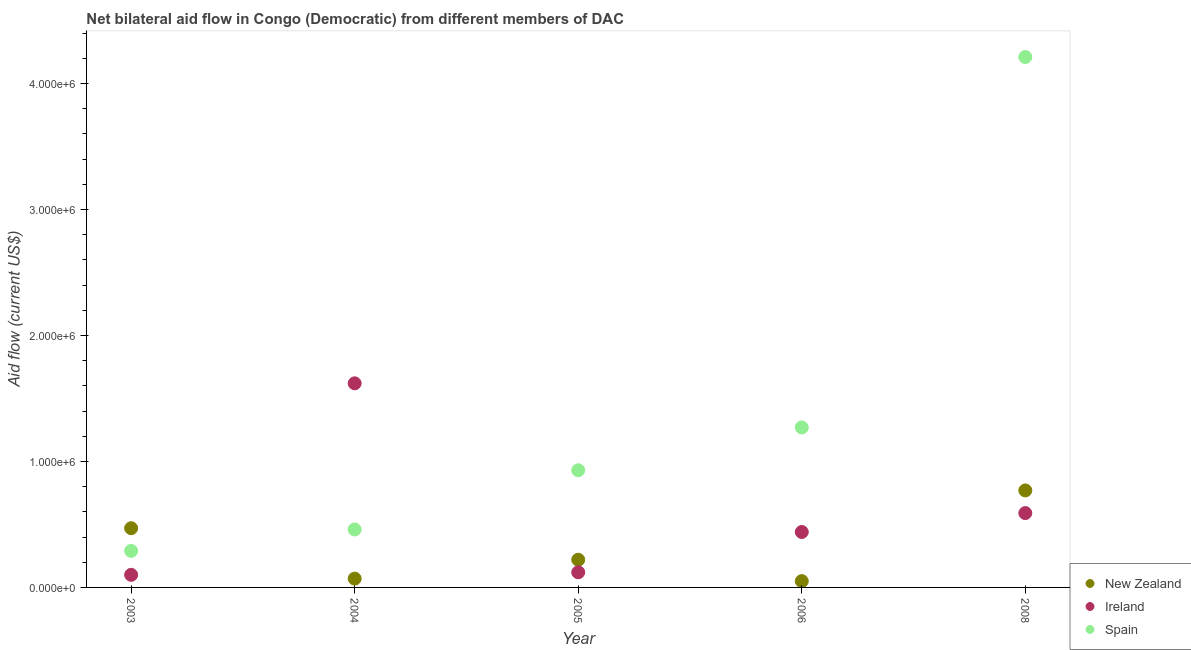How many different coloured dotlines are there?
Ensure brevity in your answer.  3. What is the amount of aid provided by spain in 2006?
Provide a succinct answer. 1.27e+06. Across all years, what is the maximum amount of aid provided by new zealand?
Your response must be concise. 7.70e+05. Across all years, what is the minimum amount of aid provided by new zealand?
Provide a succinct answer. 5.00e+04. What is the total amount of aid provided by spain in the graph?
Offer a very short reply. 7.16e+06. What is the difference between the amount of aid provided by ireland in 2003 and that in 2004?
Provide a short and direct response. -1.52e+06. What is the difference between the amount of aid provided by new zealand in 2003 and the amount of aid provided by ireland in 2006?
Offer a very short reply. 3.00e+04. What is the average amount of aid provided by new zealand per year?
Your response must be concise. 3.16e+05. In the year 2008, what is the difference between the amount of aid provided by spain and amount of aid provided by new zealand?
Provide a succinct answer. 3.44e+06. In how many years, is the amount of aid provided by new zealand greater than 2800000 US$?
Give a very brief answer. 0. What is the ratio of the amount of aid provided by ireland in 2005 to that in 2008?
Offer a terse response. 0.2. What is the difference between the highest and the second highest amount of aid provided by ireland?
Provide a succinct answer. 1.03e+06. What is the difference between the highest and the lowest amount of aid provided by ireland?
Your answer should be very brief. 1.52e+06. Is the sum of the amount of aid provided by ireland in 2006 and 2008 greater than the maximum amount of aid provided by spain across all years?
Keep it short and to the point. No. Does the amount of aid provided by ireland monotonically increase over the years?
Keep it short and to the point. No. Is the amount of aid provided by ireland strictly greater than the amount of aid provided by spain over the years?
Your response must be concise. No. How many years are there in the graph?
Provide a short and direct response. 5. Are the values on the major ticks of Y-axis written in scientific E-notation?
Provide a succinct answer. Yes. How many legend labels are there?
Offer a very short reply. 3. What is the title of the graph?
Provide a short and direct response. Net bilateral aid flow in Congo (Democratic) from different members of DAC. Does "Czech Republic" appear as one of the legend labels in the graph?
Your response must be concise. No. What is the label or title of the X-axis?
Keep it short and to the point. Year. What is the Aid flow (current US$) in Spain in 2003?
Keep it short and to the point. 2.90e+05. What is the Aid flow (current US$) of Ireland in 2004?
Provide a short and direct response. 1.62e+06. What is the Aid flow (current US$) of Spain in 2004?
Ensure brevity in your answer.  4.60e+05. What is the Aid flow (current US$) of New Zealand in 2005?
Offer a very short reply. 2.20e+05. What is the Aid flow (current US$) of Spain in 2005?
Keep it short and to the point. 9.30e+05. What is the Aid flow (current US$) of New Zealand in 2006?
Your response must be concise. 5.00e+04. What is the Aid flow (current US$) in Spain in 2006?
Provide a short and direct response. 1.27e+06. What is the Aid flow (current US$) of New Zealand in 2008?
Offer a very short reply. 7.70e+05. What is the Aid flow (current US$) of Ireland in 2008?
Your response must be concise. 5.90e+05. What is the Aid flow (current US$) in Spain in 2008?
Keep it short and to the point. 4.21e+06. Across all years, what is the maximum Aid flow (current US$) in New Zealand?
Your response must be concise. 7.70e+05. Across all years, what is the maximum Aid flow (current US$) in Ireland?
Keep it short and to the point. 1.62e+06. Across all years, what is the maximum Aid flow (current US$) of Spain?
Provide a succinct answer. 4.21e+06. Across all years, what is the minimum Aid flow (current US$) of New Zealand?
Keep it short and to the point. 5.00e+04. Across all years, what is the minimum Aid flow (current US$) of Ireland?
Make the answer very short. 1.00e+05. What is the total Aid flow (current US$) in New Zealand in the graph?
Ensure brevity in your answer.  1.58e+06. What is the total Aid flow (current US$) of Ireland in the graph?
Keep it short and to the point. 2.87e+06. What is the total Aid flow (current US$) in Spain in the graph?
Offer a terse response. 7.16e+06. What is the difference between the Aid flow (current US$) of New Zealand in 2003 and that in 2004?
Offer a very short reply. 4.00e+05. What is the difference between the Aid flow (current US$) of Ireland in 2003 and that in 2004?
Keep it short and to the point. -1.52e+06. What is the difference between the Aid flow (current US$) in Spain in 2003 and that in 2004?
Offer a terse response. -1.70e+05. What is the difference between the Aid flow (current US$) in New Zealand in 2003 and that in 2005?
Ensure brevity in your answer.  2.50e+05. What is the difference between the Aid flow (current US$) in Ireland in 2003 and that in 2005?
Ensure brevity in your answer.  -2.00e+04. What is the difference between the Aid flow (current US$) in Spain in 2003 and that in 2005?
Your answer should be very brief. -6.40e+05. What is the difference between the Aid flow (current US$) in Spain in 2003 and that in 2006?
Ensure brevity in your answer.  -9.80e+05. What is the difference between the Aid flow (current US$) in New Zealand in 2003 and that in 2008?
Your response must be concise. -3.00e+05. What is the difference between the Aid flow (current US$) in Ireland in 2003 and that in 2008?
Your answer should be very brief. -4.90e+05. What is the difference between the Aid flow (current US$) of Spain in 2003 and that in 2008?
Ensure brevity in your answer.  -3.92e+06. What is the difference between the Aid flow (current US$) of Ireland in 2004 and that in 2005?
Your answer should be very brief. 1.50e+06. What is the difference between the Aid flow (current US$) of Spain in 2004 and that in 2005?
Make the answer very short. -4.70e+05. What is the difference between the Aid flow (current US$) of Ireland in 2004 and that in 2006?
Your response must be concise. 1.18e+06. What is the difference between the Aid flow (current US$) in Spain in 2004 and that in 2006?
Your answer should be very brief. -8.10e+05. What is the difference between the Aid flow (current US$) in New Zealand in 2004 and that in 2008?
Provide a short and direct response. -7.00e+05. What is the difference between the Aid flow (current US$) of Ireland in 2004 and that in 2008?
Provide a succinct answer. 1.03e+06. What is the difference between the Aid flow (current US$) of Spain in 2004 and that in 2008?
Provide a short and direct response. -3.75e+06. What is the difference between the Aid flow (current US$) of New Zealand in 2005 and that in 2006?
Keep it short and to the point. 1.70e+05. What is the difference between the Aid flow (current US$) of Ireland in 2005 and that in 2006?
Give a very brief answer. -3.20e+05. What is the difference between the Aid flow (current US$) of New Zealand in 2005 and that in 2008?
Ensure brevity in your answer.  -5.50e+05. What is the difference between the Aid flow (current US$) of Ireland in 2005 and that in 2008?
Offer a terse response. -4.70e+05. What is the difference between the Aid flow (current US$) in Spain in 2005 and that in 2008?
Your response must be concise. -3.28e+06. What is the difference between the Aid flow (current US$) of New Zealand in 2006 and that in 2008?
Give a very brief answer. -7.20e+05. What is the difference between the Aid flow (current US$) in Ireland in 2006 and that in 2008?
Ensure brevity in your answer.  -1.50e+05. What is the difference between the Aid flow (current US$) in Spain in 2006 and that in 2008?
Your answer should be compact. -2.94e+06. What is the difference between the Aid flow (current US$) in New Zealand in 2003 and the Aid flow (current US$) in Ireland in 2004?
Keep it short and to the point. -1.15e+06. What is the difference between the Aid flow (current US$) of New Zealand in 2003 and the Aid flow (current US$) of Spain in 2004?
Offer a terse response. 10000. What is the difference between the Aid flow (current US$) of Ireland in 2003 and the Aid flow (current US$) of Spain in 2004?
Keep it short and to the point. -3.60e+05. What is the difference between the Aid flow (current US$) in New Zealand in 2003 and the Aid flow (current US$) in Spain in 2005?
Your response must be concise. -4.60e+05. What is the difference between the Aid flow (current US$) in Ireland in 2003 and the Aid flow (current US$) in Spain in 2005?
Make the answer very short. -8.30e+05. What is the difference between the Aid flow (current US$) of New Zealand in 2003 and the Aid flow (current US$) of Spain in 2006?
Offer a terse response. -8.00e+05. What is the difference between the Aid flow (current US$) of Ireland in 2003 and the Aid flow (current US$) of Spain in 2006?
Make the answer very short. -1.17e+06. What is the difference between the Aid flow (current US$) in New Zealand in 2003 and the Aid flow (current US$) in Spain in 2008?
Give a very brief answer. -3.74e+06. What is the difference between the Aid flow (current US$) of Ireland in 2003 and the Aid flow (current US$) of Spain in 2008?
Give a very brief answer. -4.11e+06. What is the difference between the Aid flow (current US$) of New Zealand in 2004 and the Aid flow (current US$) of Ireland in 2005?
Your answer should be very brief. -5.00e+04. What is the difference between the Aid flow (current US$) in New Zealand in 2004 and the Aid flow (current US$) in Spain in 2005?
Your answer should be compact. -8.60e+05. What is the difference between the Aid flow (current US$) of Ireland in 2004 and the Aid flow (current US$) of Spain in 2005?
Give a very brief answer. 6.90e+05. What is the difference between the Aid flow (current US$) of New Zealand in 2004 and the Aid flow (current US$) of Ireland in 2006?
Your answer should be very brief. -3.70e+05. What is the difference between the Aid flow (current US$) of New Zealand in 2004 and the Aid flow (current US$) of Spain in 2006?
Your response must be concise. -1.20e+06. What is the difference between the Aid flow (current US$) of Ireland in 2004 and the Aid flow (current US$) of Spain in 2006?
Give a very brief answer. 3.50e+05. What is the difference between the Aid flow (current US$) in New Zealand in 2004 and the Aid flow (current US$) in Ireland in 2008?
Provide a short and direct response. -5.20e+05. What is the difference between the Aid flow (current US$) in New Zealand in 2004 and the Aid flow (current US$) in Spain in 2008?
Offer a very short reply. -4.14e+06. What is the difference between the Aid flow (current US$) in Ireland in 2004 and the Aid flow (current US$) in Spain in 2008?
Give a very brief answer. -2.59e+06. What is the difference between the Aid flow (current US$) of New Zealand in 2005 and the Aid flow (current US$) of Ireland in 2006?
Your response must be concise. -2.20e+05. What is the difference between the Aid flow (current US$) in New Zealand in 2005 and the Aid flow (current US$) in Spain in 2006?
Offer a terse response. -1.05e+06. What is the difference between the Aid flow (current US$) in Ireland in 2005 and the Aid flow (current US$) in Spain in 2006?
Provide a short and direct response. -1.15e+06. What is the difference between the Aid flow (current US$) in New Zealand in 2005 and the Aid flow (current US$) in Ireland in 2008?
Make the answer very short. -3.70e+05. What is the difference between the Aid flow (current US$) of New Zealand in 2005 and the Aid flow (current US$) of Spain in 2008?
Offer a very short reply. -3.99e+06. What is the difference between the Aid flow (current US$) of Ireland in 2005 and the Aid flow (current US$) of Spain in 2008?
Make the answer very short. -4.09e+06. What is the difference between the Aid flow (current US$) in New Zealand in 2006 and the Aid flow (current US$) in Ireland in 2008?
Keep it short and to the point. -5.40e+05. What is the difference between the Aid flow (current US$) in New Zealand in 2006 and the Aid flow (current US$) in Spain in 2008?
Offer a terse response. -4.16e+06. What is the difference between the Aid flow (current US$) in Ireland in 2006 and the Aid flow (current US$) in Spain in 2008?
Your answer should be very brief. -3.77e+06. What is the average Aid flow (current US$) in New Zealand per year?
Give a very brief answer. 3.16e+05. What is the average Aid flow (current US$) in Ireland per year?
Keep it short and to the point. 5.74e+05. What is the average Aid flow (current US$) of Spain per year?
Give a very brief answer. 1.43e+06. In the year 2003, what is the difference between the Aid flow (current US$) of New Zealand and Aid flow (current US$) of Ireland?
Provide a succinct answer. 3.70e+05. In the year 2004, what is the difference between the Aid flow (current US$) in New Zealand and Aid flow (current US$) in Ireland?
Provide a short and direct response. -1.55e+06. In the year 2004, what is the difference between the Aid flow (current US$) in New Zealand and Aid flow (current US$) in Spain?
Provide a succinct answer. -3.90e+05. In the year 2004, what is the difference between the Aid flow (current US$) in Ireland and Aid flow (current US$) in Spain?
Your response must be concise. 1.16e+06. In the year 2005, what is the difference between the Aid flow (current US$) in New Zealand and Aid flow (current US$) in Spain?
Provide a succinct answer. -7.10e+05. In the year 2005, what is the difference between the Aid flow (current US$) of Ireland and Aid flow (current US$) of Spain?
Keep it short and to the point. -8.10e+05. In the year 2006, what is the difference between the Aid flow (current US$) of New Zealand and Aid flow (current US$) of Ireland?
Your answer should be compact. -3.90e+05. In the year 2006, what is the difference between the Aid flow (current US$) of New Zealand and Aid flow (current US$) of Spain?
Provide a succinct answer. -1.22e+06. In the year 2006, what is the difference between the Aid flow (current US$) in Ireland and Aid flow (current US$) in Spain?
Keep it short and to the point. -8.30e+05. In the year 2008, what is the difference between the Aid flow (current US$) in New Zealand and Aid flow (current US$) in Ireland?
Make the answer very short. 1.80e+05. In the year 2008, what is the difference between the Aid flow (current US$) of New Zealand and Aid flow (current US$) of Spain?
Make the answer very short. -3.44e+06. In the year 2008, what is the difference between the Aid flow (current US$) in Ireland and Aid flow (current US$) in Spain?
Offer a very short reply. -3.62e+06. What is the ratio of the Aid flow (current US$) of New Zealand in 2003 to that in 2004?
Make the answer very short. 6.71. What is the ratio of the Aid flow (current US$) in Ireland in 2003 to that in 2004?
Offer a terse response. 0.06. What is the ratio of the Aid flow (current US$) in Spain in 2003 to that in 2004?
Make the answer very short. 0.63. What is the ratio of the Aid flow (current US$) in New Zealand in 2003 to that in 2005?
Provide a short and direct response. 2.14. What is the ratio of the Aid flow (current US$) in Spain in 2003 to that in 2005?
Offer a terse response. 0.31. What is the ratio of the Aid flow (current US$) in Ireland in 2003 to that in 2006?
Your response must be concise. 0.23. What is the ratio of the Aid flow (current US$) in Spain in 2003 to that in 2006?
Ensure brevity in your answer.  0.23. What is the ratio of the Aid flow (current US$) of New Zealand in 2003 to that in 2008?
Give a very brief answer. 0.61. What is the ratio of the Aid flow (current US$) of Ireland in 2003 to that in 2008?
Offer a terse response. 0.17. What is the ratio of the Aid flow (current US$) in Spain in 2003 to that in 2008?
Your answer should be very brief. 0.07. What is the ratio of the Aid flow (current US$) in New Zealand in 2004 to that in 2005?
Offer a terse response. 0.32. What is the ratio of the Aid flow (current US$) of Spain in 2004 to that in 2005?
Keep it short and to the point. 0.49. What is the ratio of the Aid flow (current US$) of New Zealand in 2004 to that in 2006?
Offer a very short reply. 1.4. What is the ratio of the Aid flow (current US$) in Ireland in 2004 to that in 2006?
Provide a short and direct response. 3.68. What is the ratio of the Aid flow (current US$) of Spain in 2004 to that in 2006?
Offer a terse response. 0.36. What is the ratio of the Aid flow (current US$) of New Zealand in 2004 to that in 2008?
Make the answer very short. 0.09. What is the ratio of the Aid flow (current US$) of Ireland in 2004 to that in 2008?
Your answer should be very brief. 2.75. What is the ratio of the Aid flow (current US$) in Spain in 2004 to that in 2008?
Provide a short and direct response. 0.11. What is the ratio of the Aid flow (current US$) of New Zealand in 2005 to that in 2006?
Make the answer very short. 4.4. What is the ratio of the Aid flow (current US$) in Ireland in 2005 to that in 2006?
Offer a very short reply. 0.27. What is the ratio of the Aid flow (current US$) of Spain in 2005 to that in 2006?
Offer a terse response. 0.73. What is the ratio of the Aid flow (current US$) of New Zealand in 2005 to that in 2008?
Give a very brief answer. 0.29. What is the ratio of the Aid flow (current US$) of Ireland in 2005 to that in 2008?
Give a very brief answer. 0.2. What is the ratio of the Aid flow (current US$) in Spain in 2005 to that in 2008?
Provide a succinct answer. 0.22. What is the ratio of the Aid flow (current US$) of New Zealand in 2006 to that in 2008?
Your response must be concise. 0.06. What is the ratio of the Aid flow (current US$) in Ireland in 2006 to that in 2008?
Provide a succinct answer. 0.75. What is the ratio of the Aid flow (current US$) of Spain in 2006 to that in 2008?
Offer a very short reply. 0.3. What is the difference between the highest and the second highest Aid flow (current US$) of New Zealand?
Your answer should be very brief. 3.00e+05. What is the difference between the highest and the second highest Aid flow (current US$) of Ireland?
Provide a short and direct response. 1.03e+06. What is the difference between the highest and the second highest Aid flow (current US$) in Spain?
Make the answer very short. 2.94e+06. What is the difference between the highest and the lowest Aid flow (current US$) of New Zealand?
Offer a very short reply. 7.20e+05. What is the difference between the highest and the lowest Aid flow (current US$) in Ireland?
Your answer should be compact. 1.52e+06. What is the difference between the highest and the lowest Aid flow (current US$) of Spain?
Ensure brevity in your answer.  3.92e+06. 